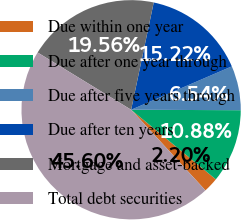Convert chart to OTSL. <chart><loc_0><loc_0><loc_500><loc_500><pie_chart><fcel>Due within one year<fcel>Due after one year through<fcel>Due after five years through<fcel>Due after ten years<fcel>Mortgage and asset-backed<fcel>Total debt securities<nl><fcel>2.2%<fcel>10.88%<fcel>6.54%<fcel>15.22%<fcel>19.56%<fcel>45.6%<nl></chart> 